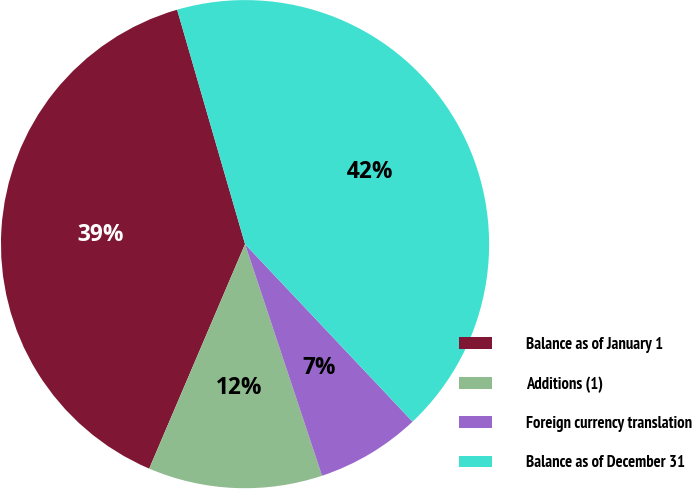Convert chart. <chart><loc_0><loc_0><loc_500><loc_500><pie_chart><fcel>Balance as of January 1<fcel>Additions (1)<fcel>Foreign currency translation<fcel>Balance as of December 31<nl><fcel>39.09%<fcel>11.53%<fcel>6.93%<fcel>42.45%<nl></chart> 